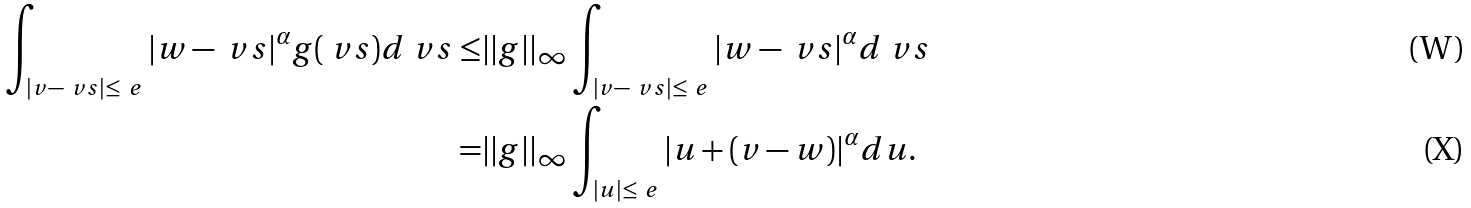Convert formula to latex. <formula><loc_0><loc_0><loc_500><loc_500>\int _ { | v - \ v s | \leq \ e } | w - \ v s | ^ { \alpha } g ( \ v s ) d \ v s \leq & | | g | | _ { \infty } \int _ { | v - \ v s | \leq \ e } | w - \ v s | ^ { \alpha } d \ v s \\ = & | | g | | _ { \infty } \int _ { | u | \leq \ e } | u + ( v - w ) | ^ { \alpha } d u .</formula> 